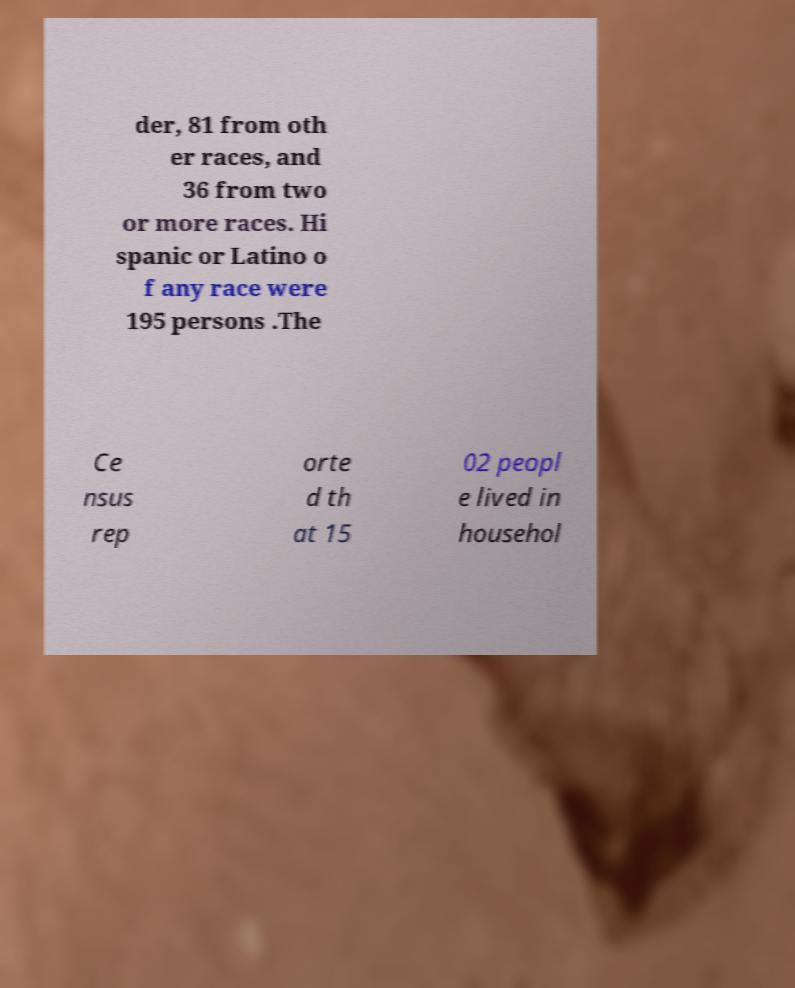There's text embedded in this image that I need extracted. Can you transcribe it verbatim? der, 81 from oth er races, and 36 from two or more races. Hi spanic or Latino o f any race were 195 persons .The Ce nsus rep orte d th at 15 02 peopl e lived in househol 